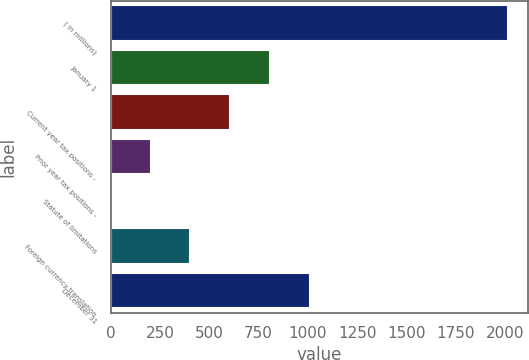Convert chart. <chart><loc_0><loc_0><loc_500><loc_500><bar_chart><fcel>( in millions)<fcel>January 1<fcel>Current year tax positions -<fcel>Prior year tax positions -<fcel>Statute of limitations<fcel>Foreign currency translation<fcel>December 31<nl><fcel>2015<fcel>806.6<fcel>605.2<fcel>202.4<fcel>1<fcel>403.8<fcel>1008<nl></chart> 